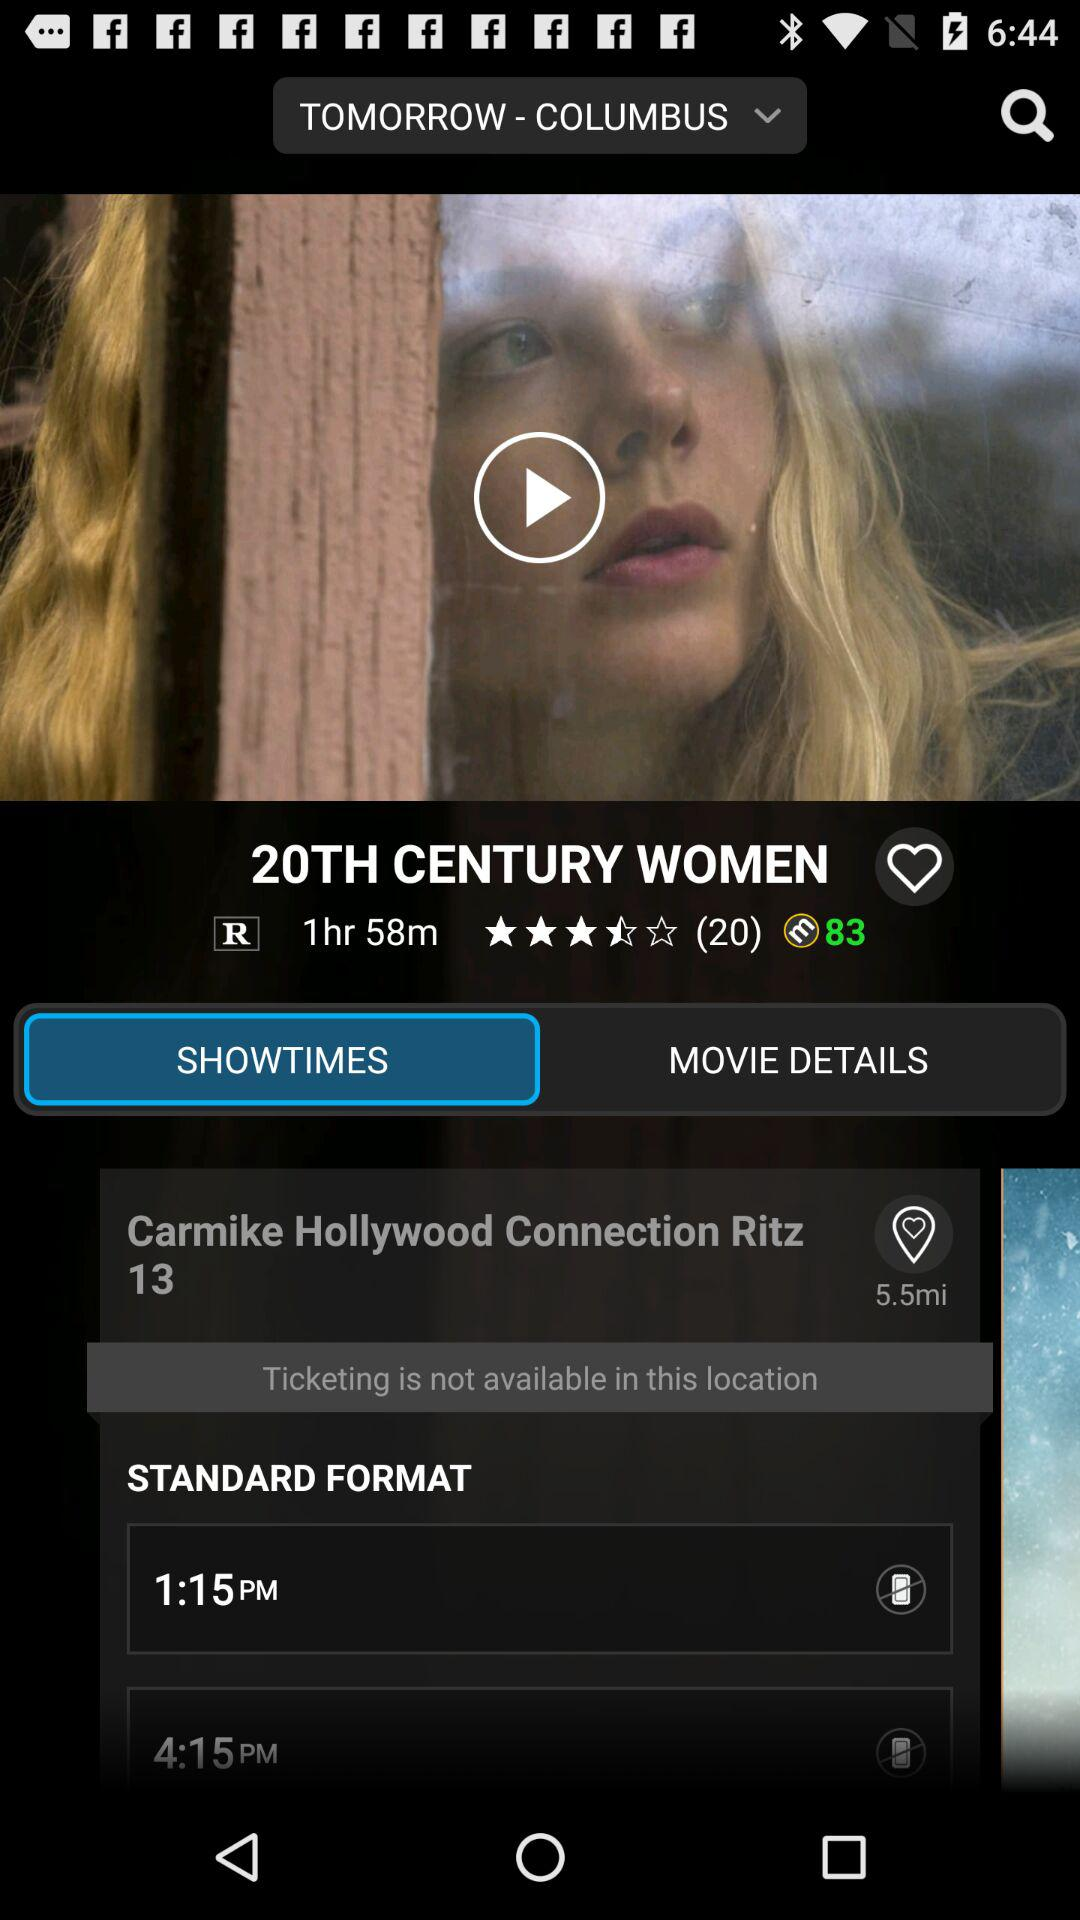How much is the distance of Carmike Hollywood Connection Ritz 13 from my location? The distance is 5.5 miles. 